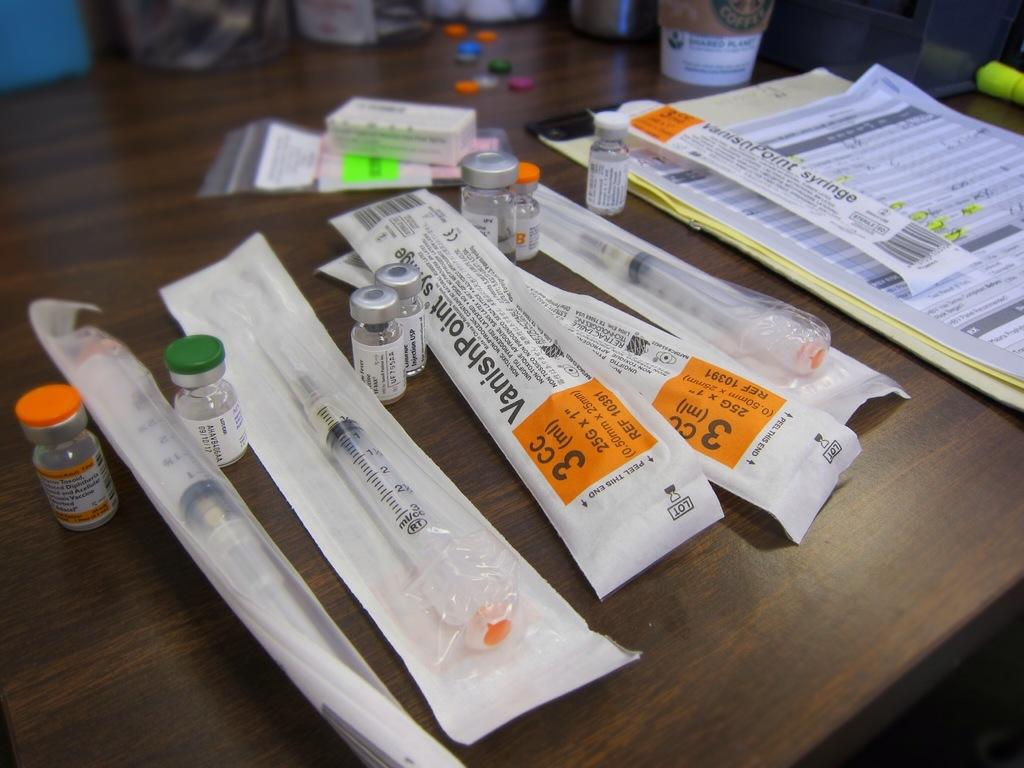Provide a one-sentence caption for the provided image. the number 3 is on the paper item. 